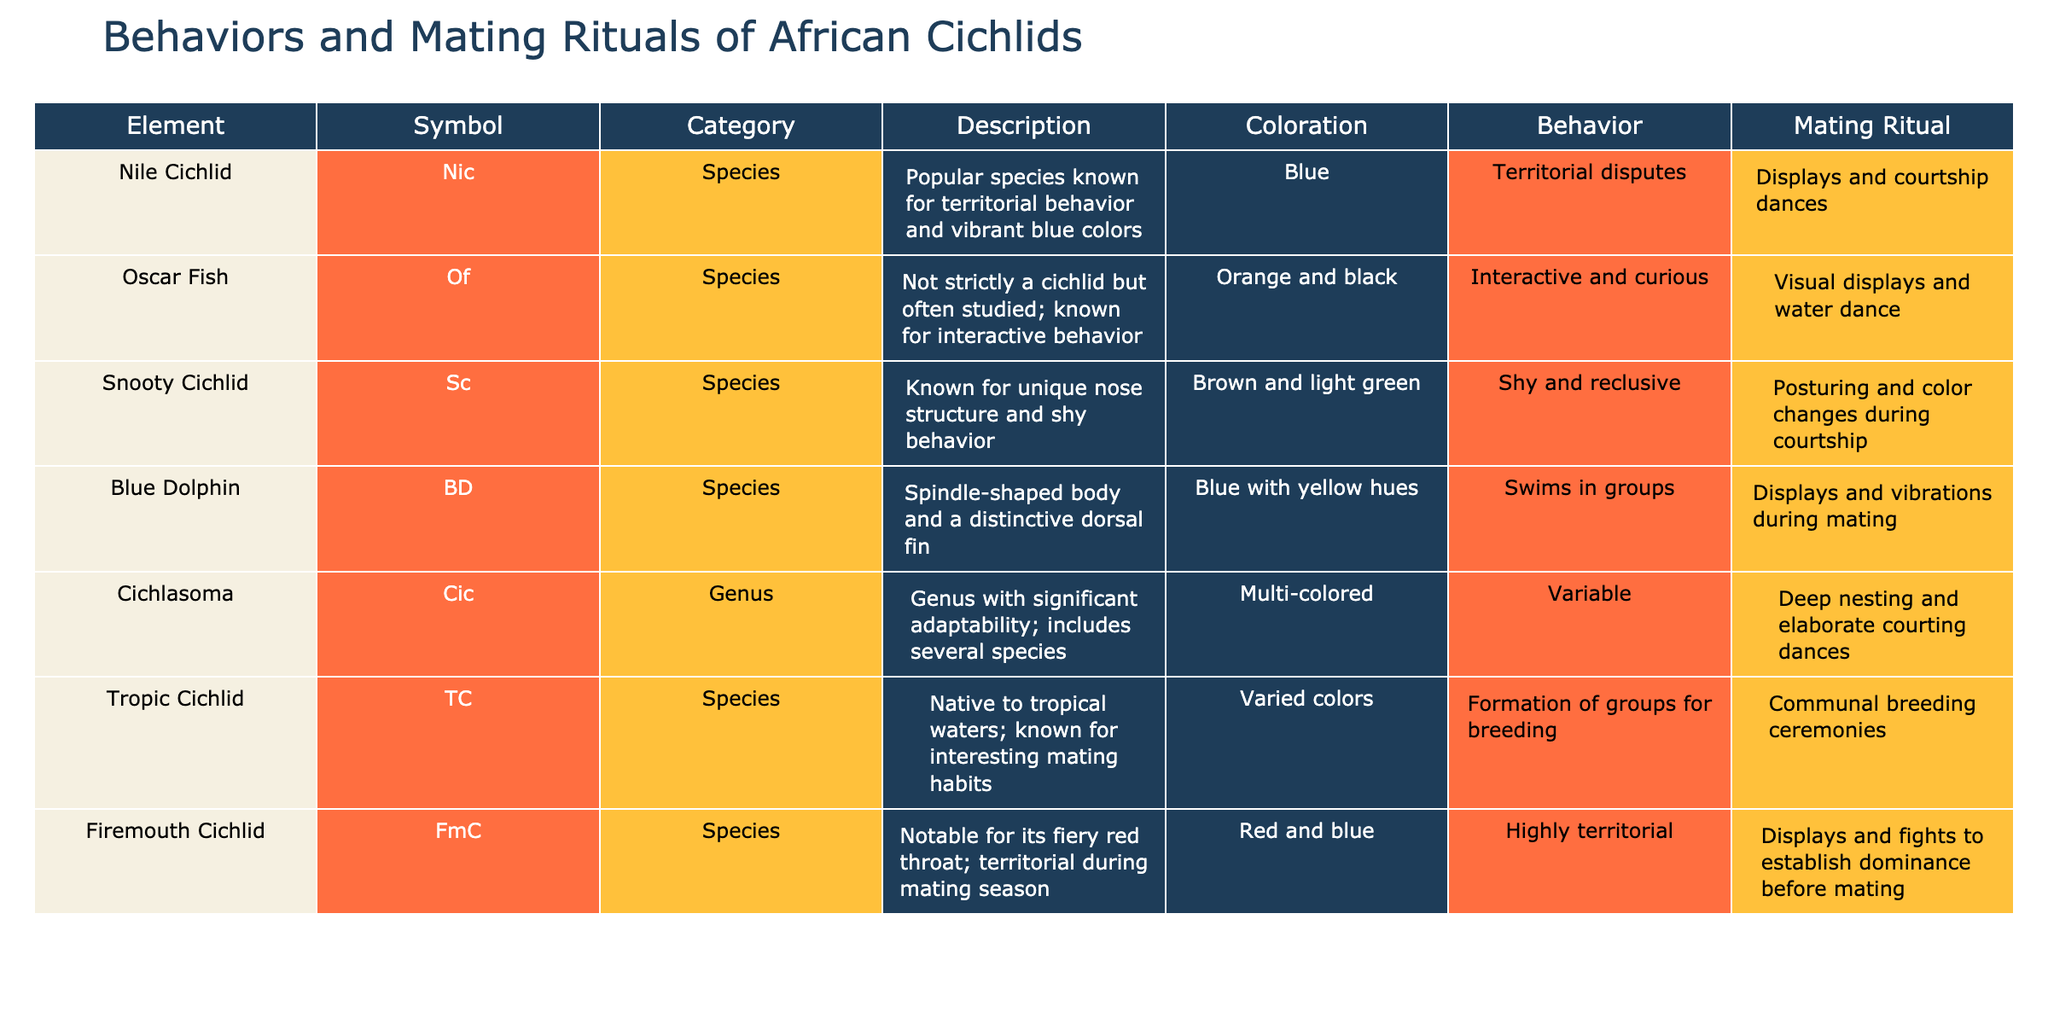What mating ritual does the Firemouth Cichlid perform? The table lists "Displays and fights to establish dominance before mating" under the "Mating Ritual" column for the Firemouth Cichlid, directly answering the question.
Answer: Displays and fights to establish dominance before mating Which cichlid is known for its interactive behavior? Referring to the table, the Oscar Fish is the only one mentioned for its interactive behavior in the "Behavior" column.
Answer: Oscar Fish How many species in the table display territorial behavior? There are three species that show territorial behavior: Nile Cichlid, Firemouth Cichlid, and Cichlasoma. Summing these gives a total of three species.
Answer: 3 Does the Blue Dolphin engage in shy behavior? Looking at the "Behavior" column, the Blue Dolphin engages in a group-swimming behavior, which means it does not exhibit shy behavior. Therefore, the answer is no.
Answer: No Which species displays distinctive coloration patterns? By examining the "Coloration" column, both the Nile Cichlid and Blue Dolphin are associated with unique coloration patterns (blue and blue with yellow hues). Thus, both species exhibit distinctive colors.
Answer: Nile Cichlid and Blue Dolphin What is the behavioral pattern of the Snooty Cichlid? The table states the behavior of the Snooty Cichlid as "Shy and reclusive," directly providing the answer regarding its behavioral pattern.
Answer: Shy and reclusive How many species practice communal breeding ceremonies? The table indicates that only the Tropic Cichlid engages in communal breeding ceremonies under "Mating Ritual," leading to the answer.
Answer: 1 What is the primary color of the Firemouth Cichlid? According to the "Coloration" column in the table, the Firemouth Cichlid is primarily red and blue.
Answer: Red and blue What do all cichlids in the table have in common concerning mating rituals? All the cichlids listed in the table have specific mating rituals, varying from displays to courting dances. The commonality is that they all have defined rituals.
Answer: They all have specific mating rituals 